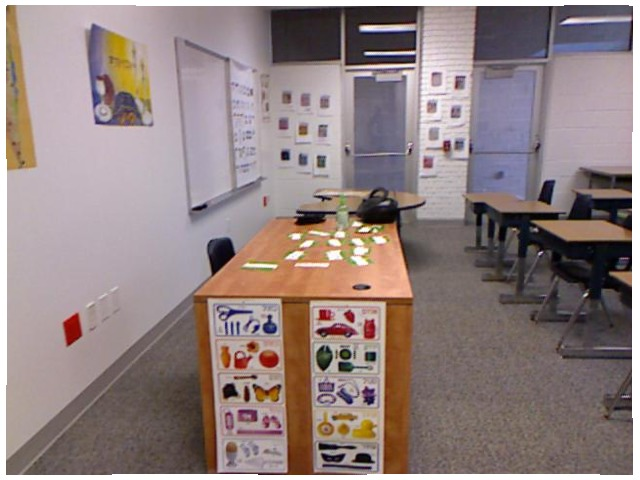<image>
Is the stereo on the table? No. The stereo is not positioned on the table. They may be near each other, but the stereo is not supported by or resting on top of the table. Is there a outlet behind the chair? Yes. From this viewpoint, the outlet is positioned behind the chair, with the chair partially or fully occluding the outlet. Where is the chair in relation to the desk? Is it under the desk? Yes. The chair is positioned underneath the desk, with the desk above it in the vertical space. Is there a butterfly under the watering can? Yes. The butterfly is positioned underneath the watering can, with the watering can above it in the vertical space. Where is the poster in relation to the window? Is it under the window? No. The poster is not positioned under the window. The vertical relationship between these objects is different. Where is the chair in relation to the desk? Is it under the desk? No. The chair is not positioned under the desk. The vertical relationship between these objects is different. 